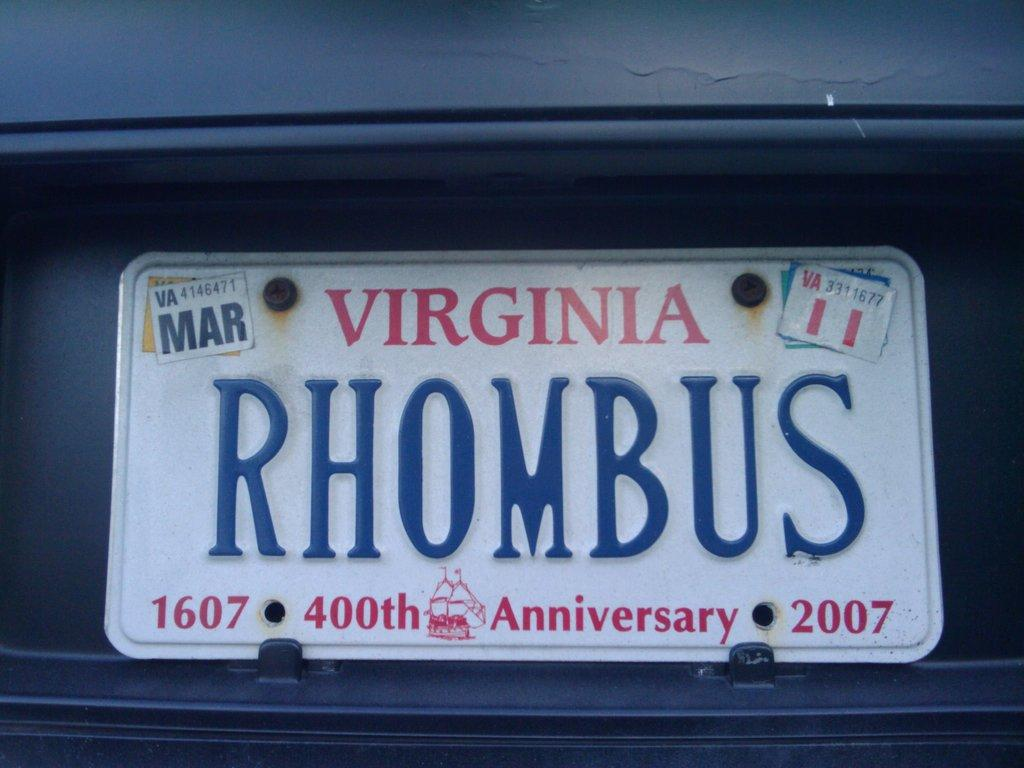<image>
Create a compact narrative representing the image presented. White Virginia license plate which says RHOMBUS on it. 